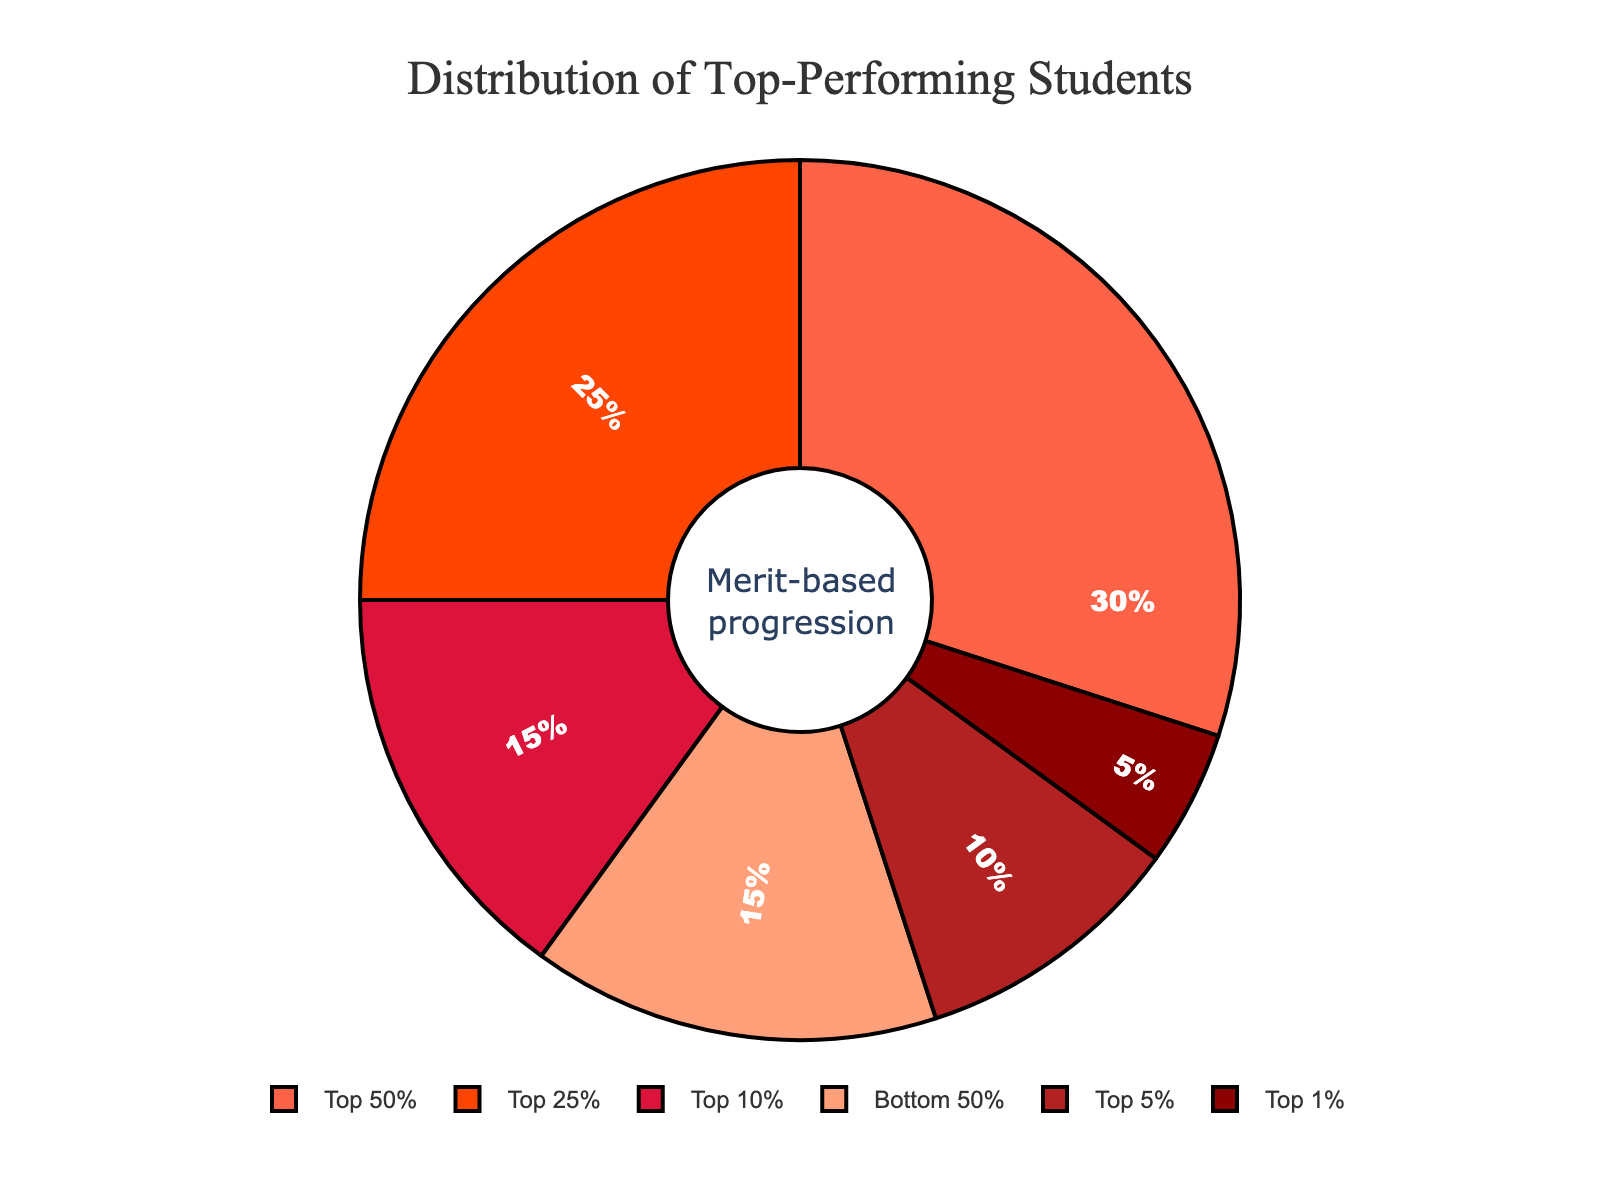What percentage of students are in the top 10%? The pie chart shows that the "Top 10%" slice represents 15% of the students.
Answer: 15% What is the total percentage of students in the top 25%? Sum the percentages of the "Top 1%", "Top 5%", and "Top 10%" slices, which are (5% + 10% + 15%). This gives a total of 30%. The "Top 25%" slice represents another 25%, giving a total of 30% + 25% = 55%.
Answer: 55% Which group has the least percentage of students? By visually inspecting the pie chart, the "Top 1%" slice is the smallest, representing 5%.
Answer: Top 1% How does the percentage of students in the bottom 50% compare to those in the top 1%? The pie chart shows that the "Bottom 50%" slice is 15%, while the "Top 1%" slice is 5%. Therefore, the percentage of students in the bottom 50% is three times larger than that in the top 1%.
Answer: Three times larger What is the combined percentage of students in the top 50% and bottom 50%? From the pie chart, the "Top 50%" is 30% and the "Bottom 50%" is 15%. Adding these together gives 30% + 15% = 45%.
Answer: 45% How much larger is the Top 5% section compared to the Top 1% section? The "Top 5%" section is 10%, and the "Top 1%" section is 5%. Subtracting these values gives 10% - 5% = 5%.
Answer: 5% larger Is the percentage of students in the Top 25% more than half of the total students in the top 50%? The "Top 25%" slice represents 25%, and the "Top 50%" slice represents 30%. Half of the "Top 50%" slice is 30% / 2 = 15%. Since 25% > 15%, the "Top 25%" percentage is indeed more than half of the "Top 50%".
Answer: Yes What is the ratio of students in the Top 10% to those in the Bottom 50%? The pie chart indicates that the "Top 10%" represents 15%, while the "Bottom 50%" represents 15%. Therefore, their ratio is 15%/15% = 1.
Answer: 1:1 Which groups have an equal percentage, and what is that percentage? Inspecting the pie chart, we see that "Top 10%" and "Bottom 50%" both represent 15%.
Answer: Top 10% and Bottom 50%, 15% What fraction of the total student body do the Top 5% and Bottom 50% represent together? The "Top 5%" slice is 10%, and the "Bottom 50%" slice is 15%. Adding these percentages gives 10% + 15% = 25%. As a fraction, this is 25/100, which simplifies to 1/4.
Answer: 1/4 